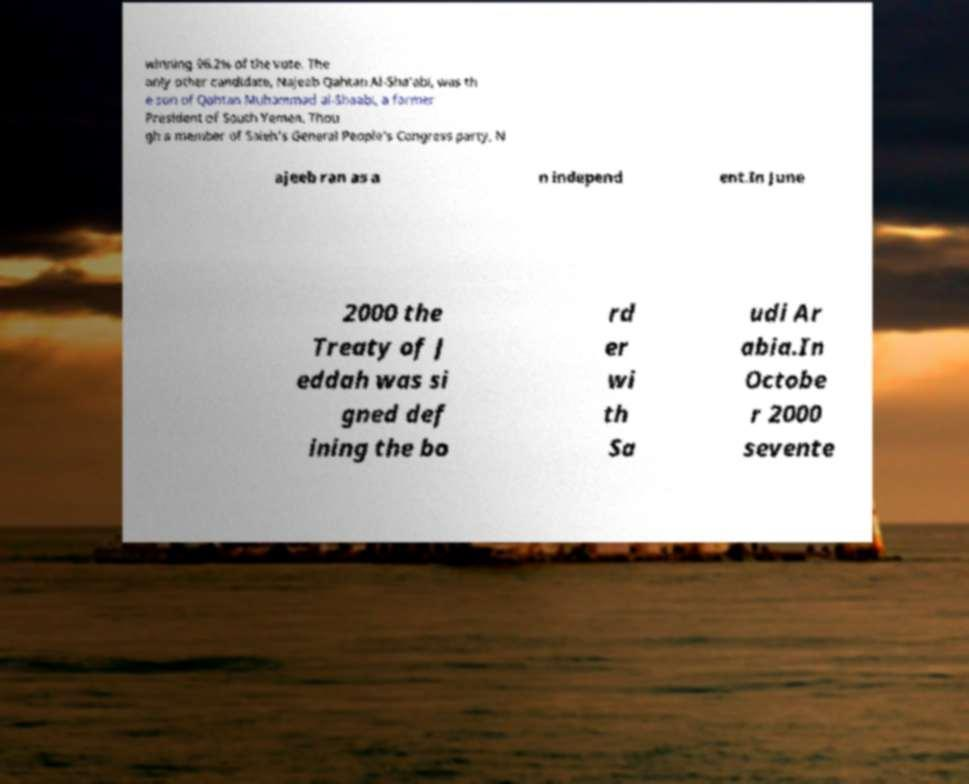Could you extract and type out the text from this image? winning 96.2% of the vote. The only other candidate, Najeeb Qahtan Al-Sha'abi, was th e son of Qahtan Muhammad al-Shaabi, a former President of South Yemen. Thou gh a member of Saleh's General People's Congress party, N ajeeb ran as a n independ ent.In June 2000 the Treaty of J eddah was si gned def ining the bo rd er wi th Sa udi Ar abia.In Octobe r 2000 sevente 